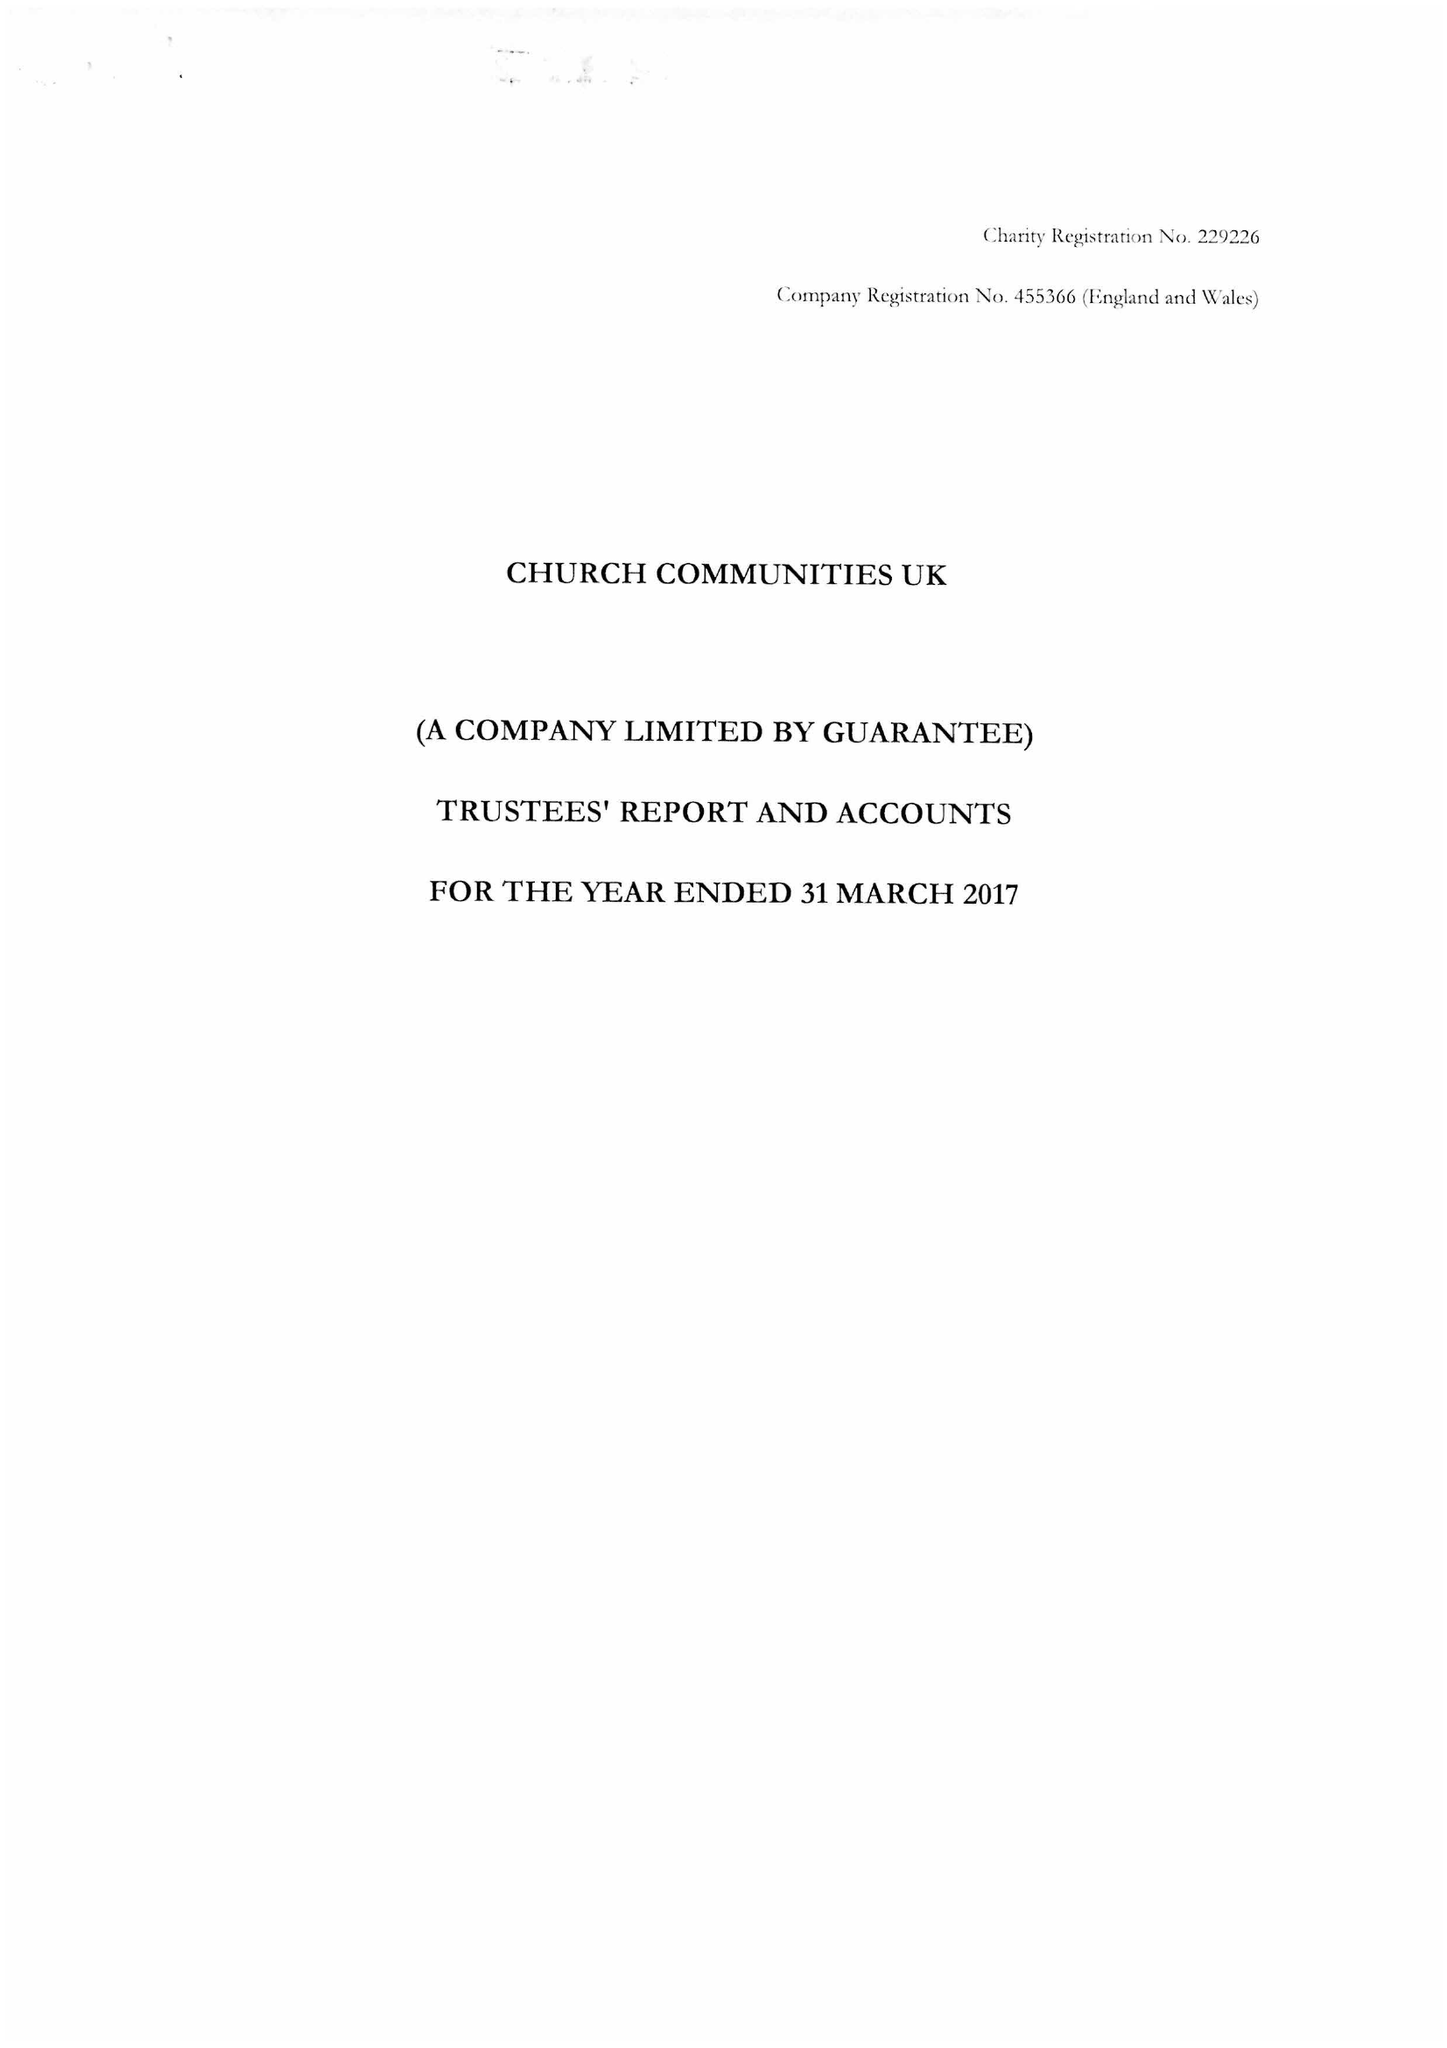What is the value for the charity_name?
Answer the question using a single word or phrase. Church Communities Uk 